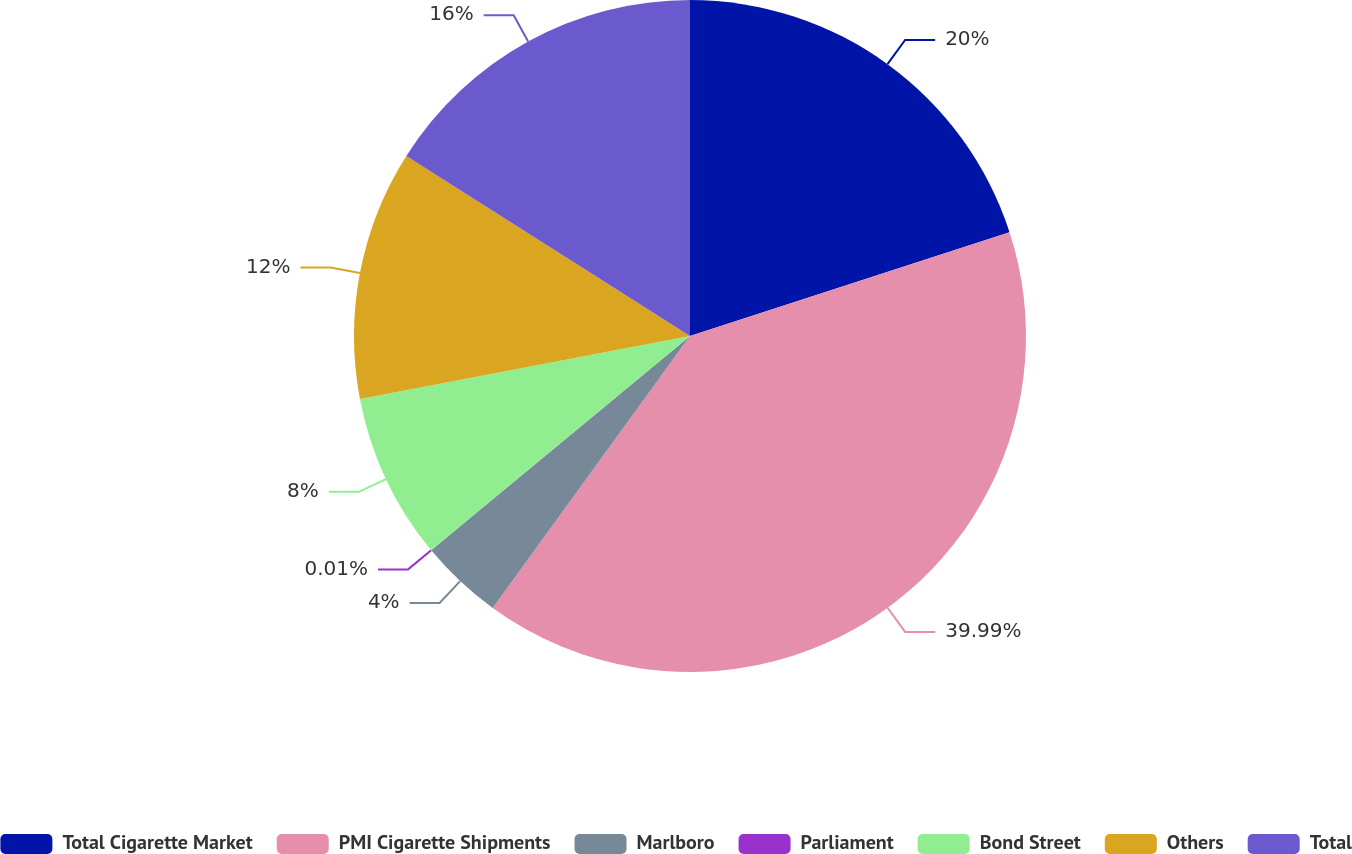Convert chart to OTSL. <chart><loc_0><loc_0><loc_500><loc_500><pie_chart><fcel>Total Cigarette Market<fcel>PMI Cigarette Shipments<fcel>Marlboro<fcel>Parliament<fcel>Bond Street<fcel>Others<fcel>Total<nl><fcel>20.0%<fcel>39.99%<fcel>4.0%<fcel>0.01%<fcel>8.0%<fcel>12.0%<fcel>16.0%<nl></chart> 